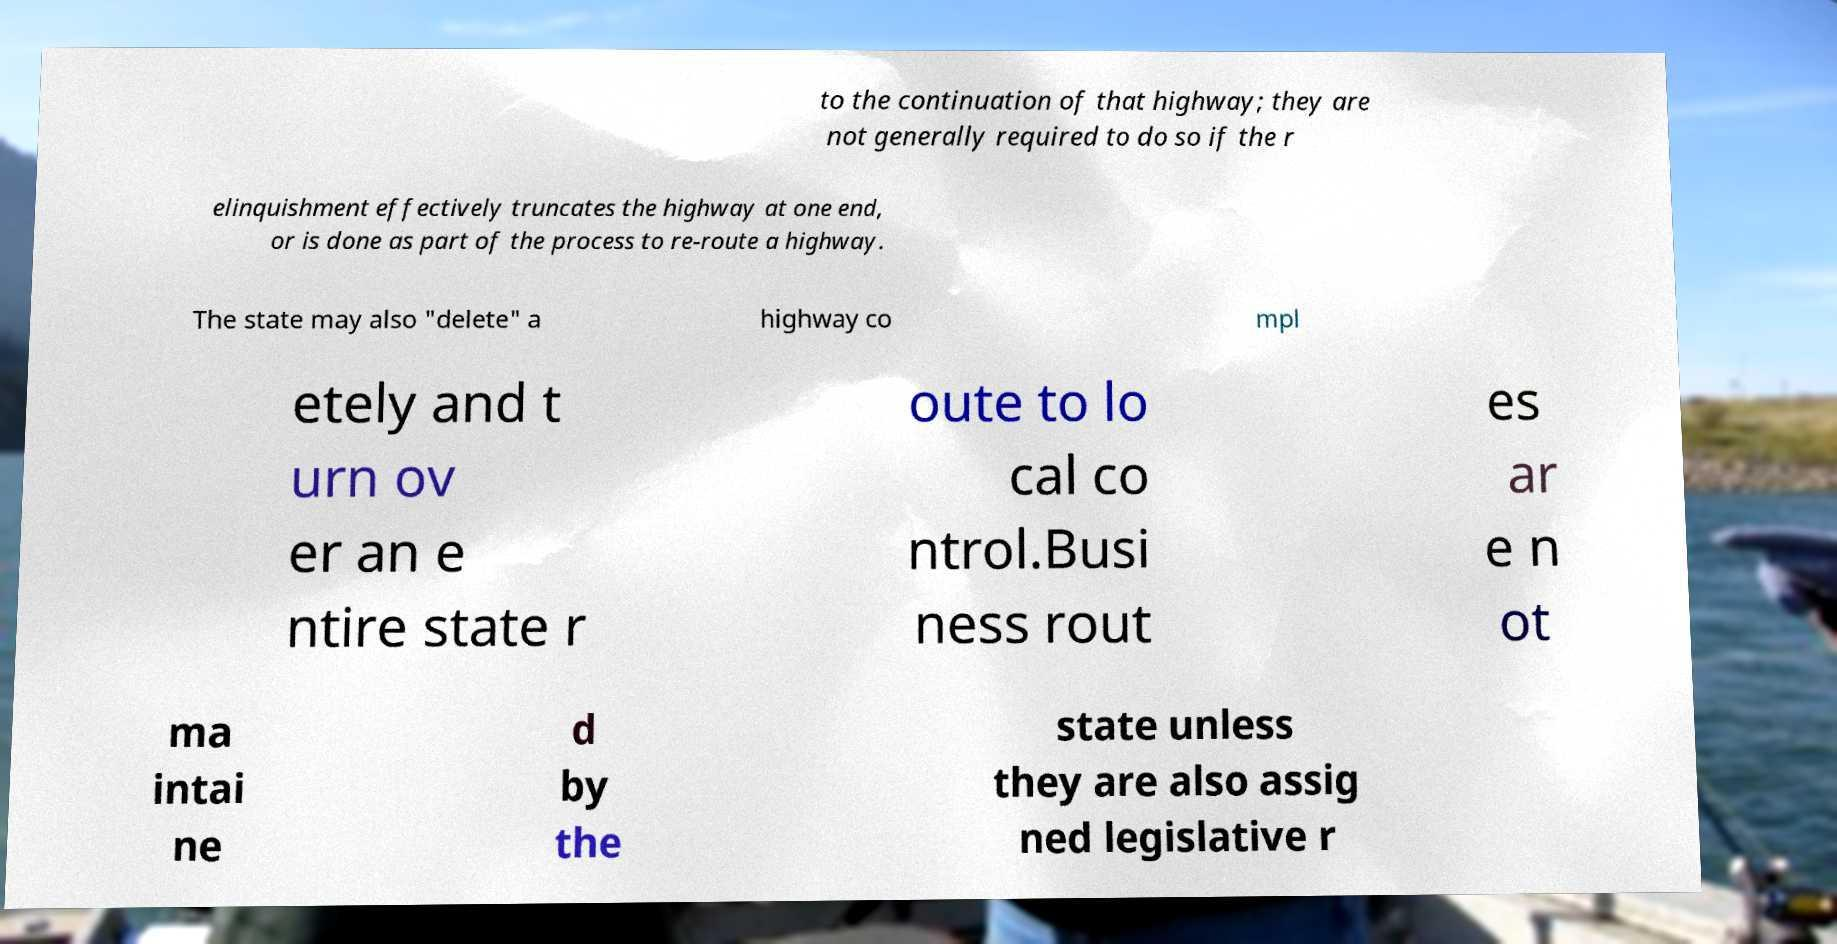Could you assist in decoding the text presented in this image and type it out clearly? to the continuation of that highway; they are not generally required to do so if the r elinquishment effectively truncates the highway at one end, or is done as part of the process to re-route a highway. The state may also "delete" a highway co mpl etely and t urn ov er an e ntire state r oute to lo cal co ntrol.Busi ness rout es ar e n ot ma intai ne d by the state unless they are also assig ned legislative r 